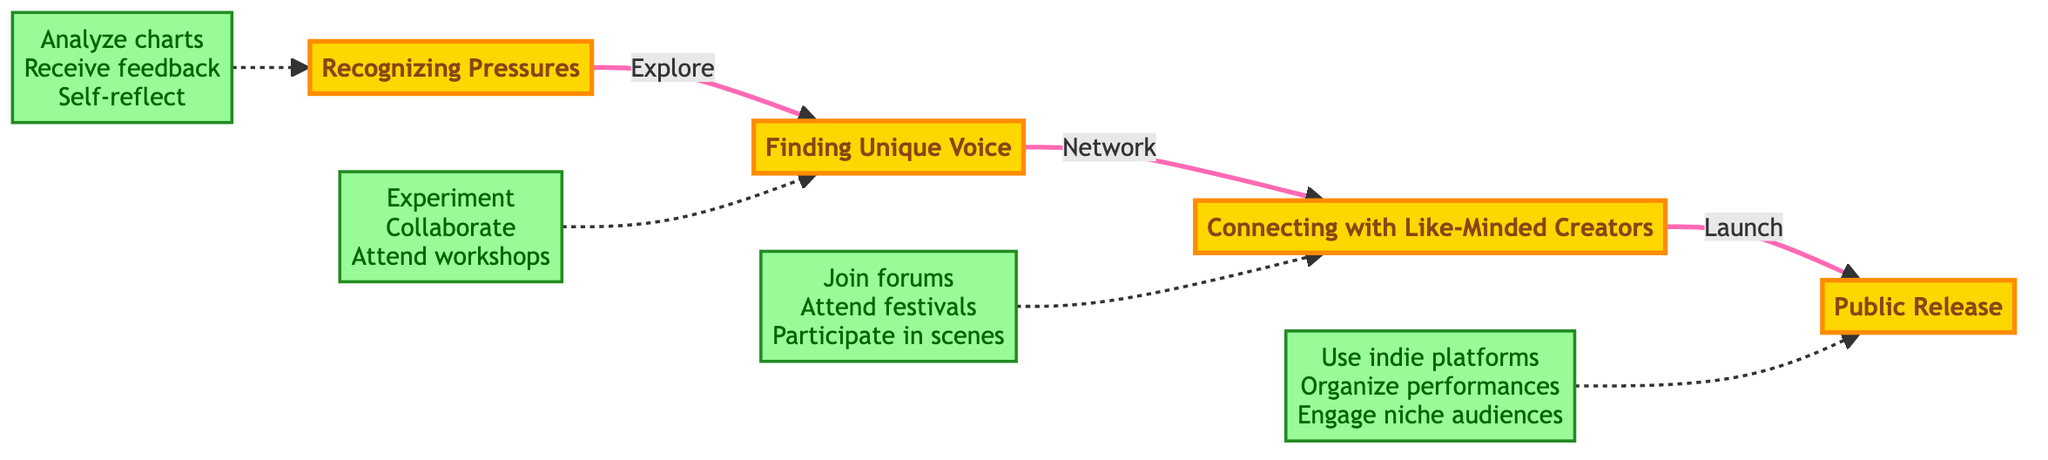What is the first step in the journey? The diagram starts with the node labeled "Recognizing Pressures," which indicates it is the initial phase of breaking free from mainstream influence.
Answer: Recognizing Pressures How many main steps are there in the diagram? By counting the nodes that represent main steps, we find there are four nodes in total: Recognizing Pressures, Finding Unique Voice, Connecting with Like-Minded Creators, and Public Release.
Answer: 4 What tool is used in the 'Finding Unique Voice' step? The diagram lists "Music production software (Ableton Live)" as one of the tools used in the Finding Unique Voice step, indicating its importance in this phase.
Answer: Music production software (Ableton Live) Which step involves networking? The arrow labeled "Network" connects the "Finding Unique Voice" step to the "Connecting with Like-Minded Creators" step, indicating that networking occurs during this phase of the journey.
Answer: Connecting with Like-Minded Creators What activities are associated with the 'Public Release' step? The diagram specifies three activities associated with the Public Release step: "Utilize independent music platforms," "Organize unique live performances," and "Engage with niche audiences through social media."
Answer: Utilize independent music platforms, Organize unique live performances, Engage with niche audiences through social media What is the last step in the journey? The diagram indicates that the final step is "Public Release," which concludes the journey of breaking free from mainstream influences in music.
Answer: Public Release Which step comes before 'Connecting with Like-Minded Creators'? The flowchart shows an arrow leading from "Finding Unique Voice" to "Connecting with Like-Minded Creators," indicating that the former is the preceding step.
Answer: Finding Unique Voice What connection does the step 'Recognizing Pressures' lead to? The arrow from "Recognizing Pressures" points directly to "Finding Unique Voice," showing that the first step directly influences the next in the journey toward artistic freedom.
Answer: Finding Unique Voice What is a detailed activity suggested in the 'Connecting with Like-Minded Creators' step? The associated activities listed for this step include joining experimental music forums, alongside attending festivals and participating in underground music scenes, demonstrating community-building.
Answer: Join experimental music forums 